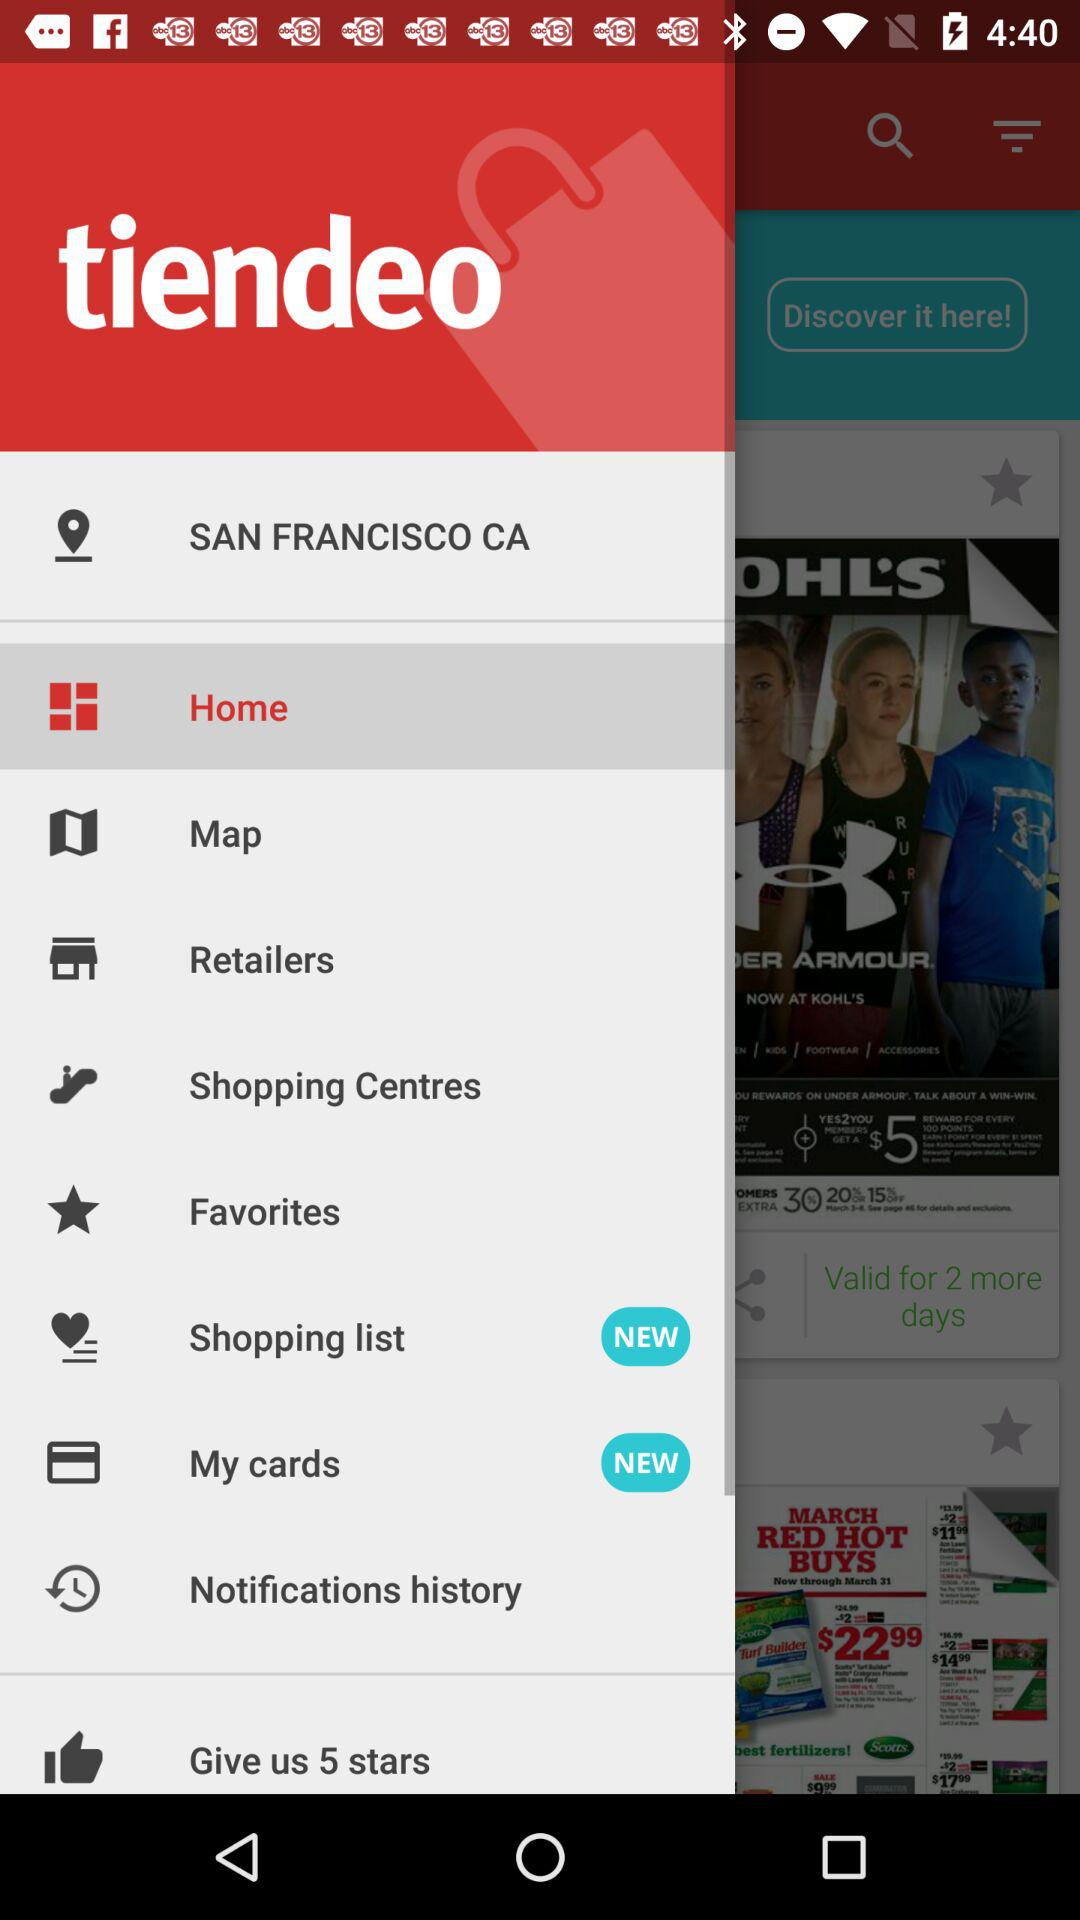Where are the new items added? The new items are added to "Shopping list" and "My cards". 